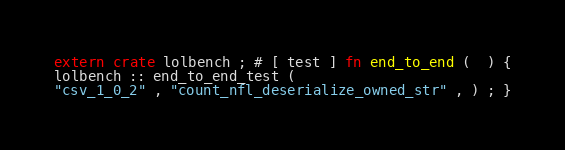Convert code to text. <code><loc_0><loc_0><loc_500><loc_500><_Rust_>extern crate lolbench ; # [ test ] fn end_to_end (  ) {
lolbench :: end_to_end_test (
"csv_1_0_2" , "count_nfl_deserialize_owned_str" , ) ; }</code> 